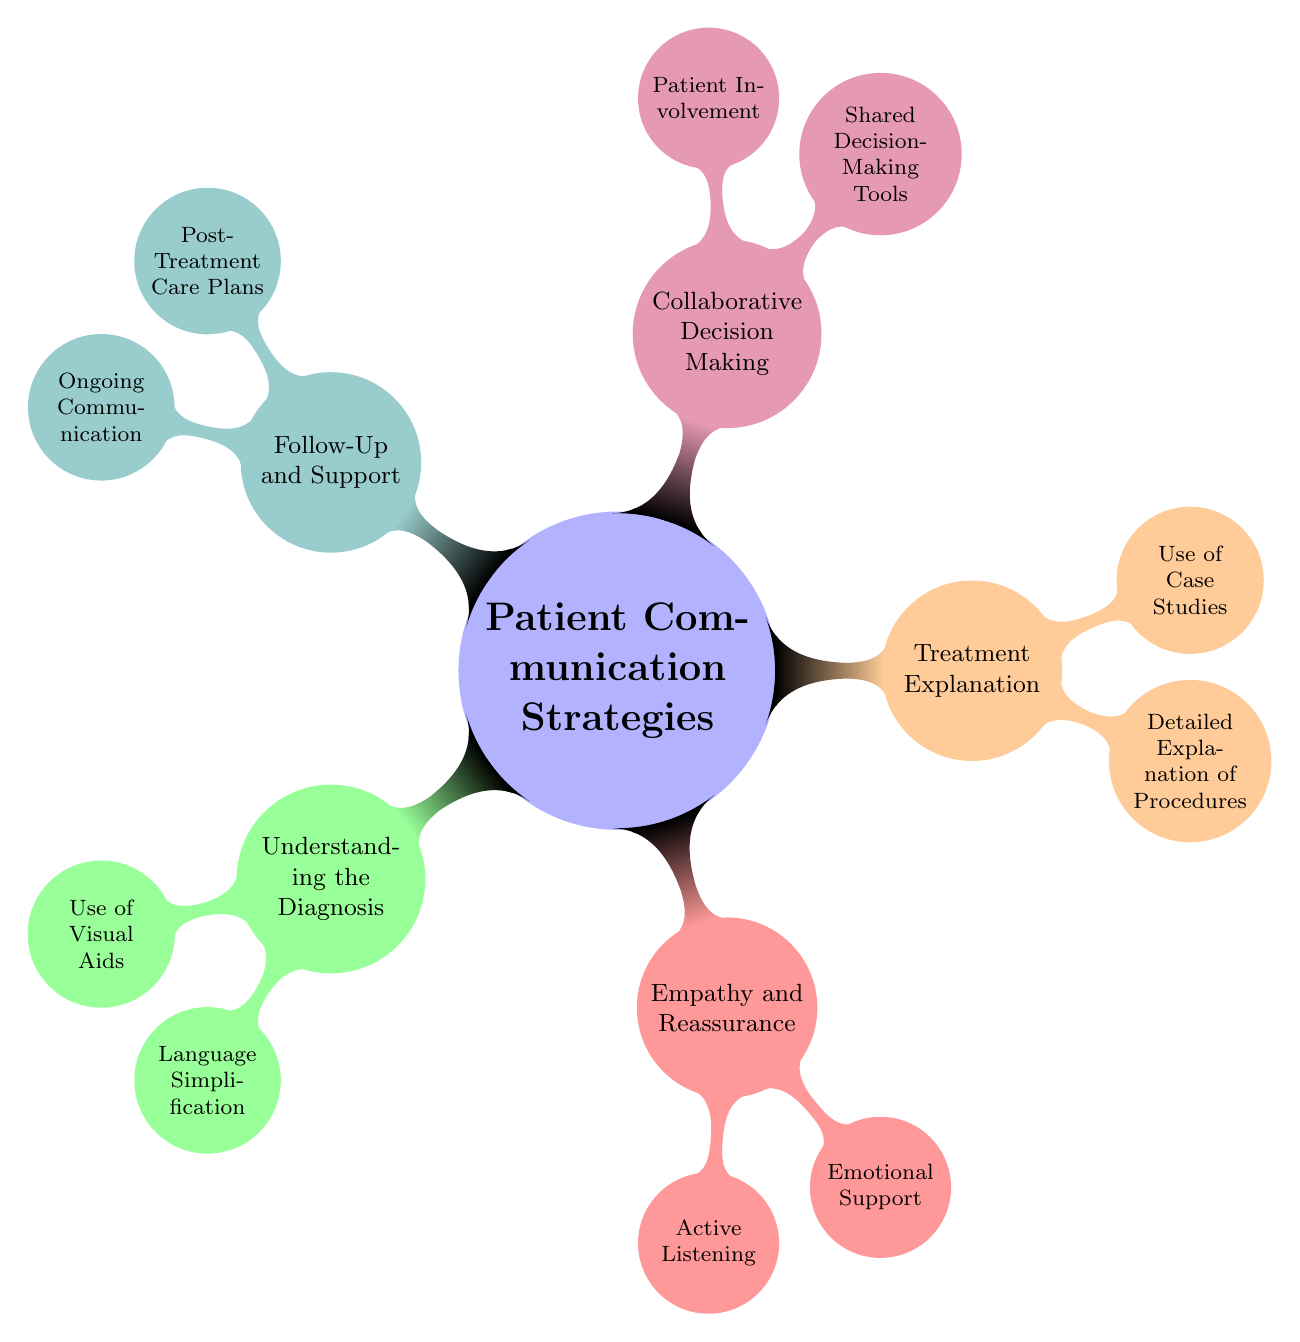What is the central theme of the mind map? The main topic of the mind map is "Patient Communication Strategies." This is the primary node from which all other nodes branch out, indicating that it is the focal point of the diagram.
Answer: Patient Communication Strategies How many main branches are present in the diagram? The diagram has five main branches emerging from the central theme, each representing a different aspect of patient communication. These branches are: Understanding the Diagnosis, Empathy and Reassurance, Treatment Explanation, Collaborative Decision Making, and Follow-Up and Support.
Answer: 5 What is one strategy listed under "Empathy and Reassurance"? Under the "Empathy and Reassurance" branch, the diagram lists "Active Listening" as one strategy. This indicates the importance of attentiveness and engagement in patient communication.
Answer: Active Listening What type of tools are mentioned under "Collaborative Decision Making"? The mind map specifies "Shared Decision-Making Tools" as a key aspect under the "Collaborative Decision Making" category, highlighting tools that assist in involving patients in their treatment options.
Answer: Shared Decision-Making Tools Which branch focuses on the patient's ongoing needs post-treatment? The "Follow-Up and Support" branch is specifically dedicated to addressing the ongoing needs of patients after treatment, ensuring they have the necessary care plans and communication avenues to support their recovery.
Answer: Follow-Up and Support Which strategy under "Understanding the Diagnosis" helps simplify complex medical concepts? "Language Simplification" is a strategy under "Understanding the Diagnosis" that aims to make complex medical information more accessible to patients, using simpler terms and analogies.
Answer: Language Simplification How does "Active Listening" relate to the concept of "Empathy and Reassurance"? "Active Listening" is a strategy listed under "Empathy and Reassurance." It emphasizes the significance of understanding a patient's feelings and concerns, which is essential for providing emotional support and reassurance.
Answer: Active Listening What is an example of a visual aid used to help patients understand their diagnosis? "Diagnostic Images" are mentioned as visual aids under the "Use of Visual Aids" node, showcasing how these aids assist patients in comprehending their medical conditions better.
Answer: Diagnostic Images Name a method for explaining treatment outcomes mentioned in the mind map. The mind map includes "Possible Outcomes" as a method for explaining treatment, indicating that discussing potential results is crucial for patient understanding and decision-making.
Answer: Possible Outcomes 